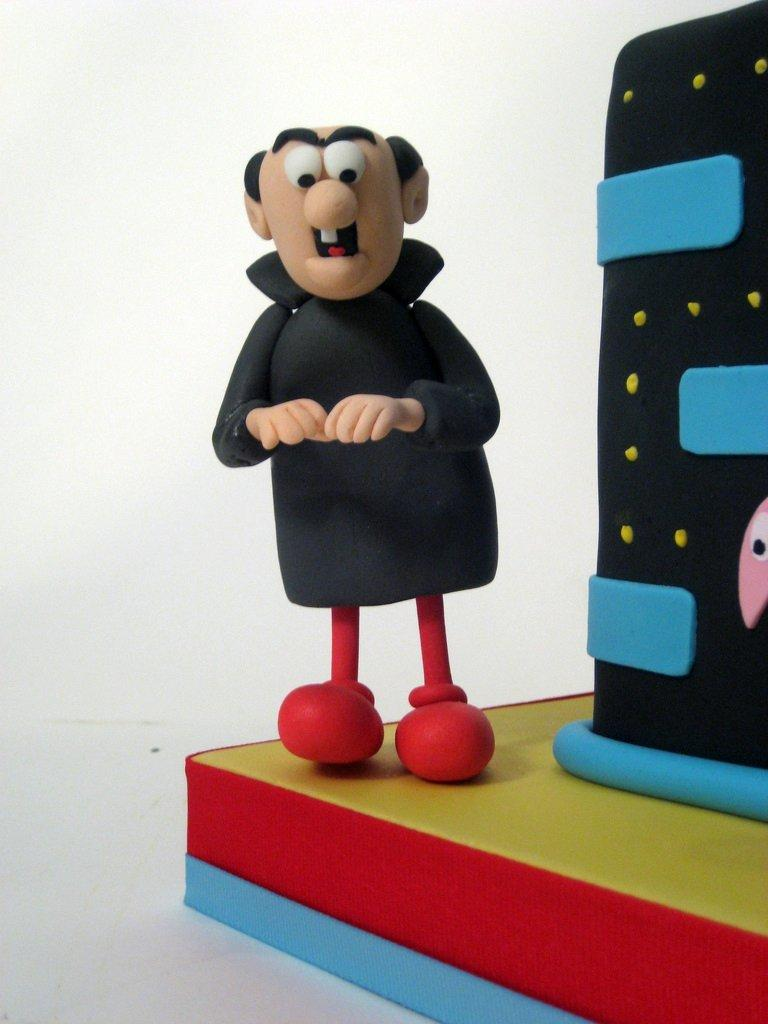What is the main subject in the foreground of the image? There is a cartoon toy in the foreground of the image. What can be seen in the background of the image? The background of the image is white. Is there any architectural feature visible in the image? Yes, there is a wall in the image. How much honey does the cartoon toy have in the image? There is no honey present in the image, as it features a cartoon toy and a wall with a white background. 